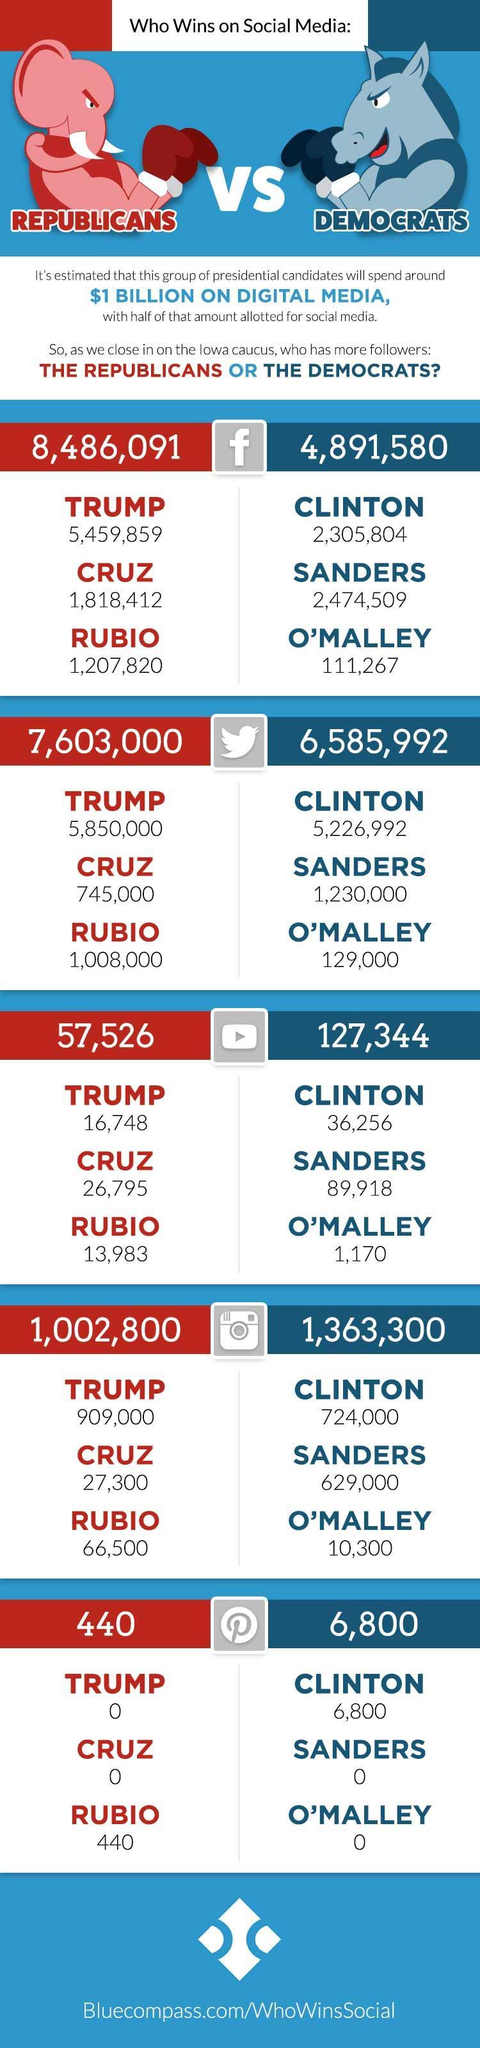On which social media platform did the Democrats have the highest number of followers - Facebook, Twitter or Instagram?
Answer the question with a short phrase. Twitter How many followers does Clinton have on Pinterest? 6,800 Who has more followers on Pinterest, Republicans or Democrats? Democrats How many followers does Trump have on Pinterest? 0 Which Republican candidate has the the highest followers on Pinterest? Rubio Who are the three Democrats candidates? Clinton, Sanders, O'Malley Which Democrats candidate had the highest number of followers on Facebook? Sanders Who had more followers on Instagram, Trump or Clinton? Trump How many followers did Sanders have on Pinterest? 0 Who has more followers on Facebook, Trump or Clinton? Trump On which social media platform did the Republicans have the highest number of followers - Facebook, Twitter or Instagram? Facebook Who were the three candidates for the republicans? Trump, Cruz, Rubio Which candidate had the highest number of followers on YouTube? Sanders Which political party is represented by the donkey? Democrats Which political party is represented by the elephant? Republicans 